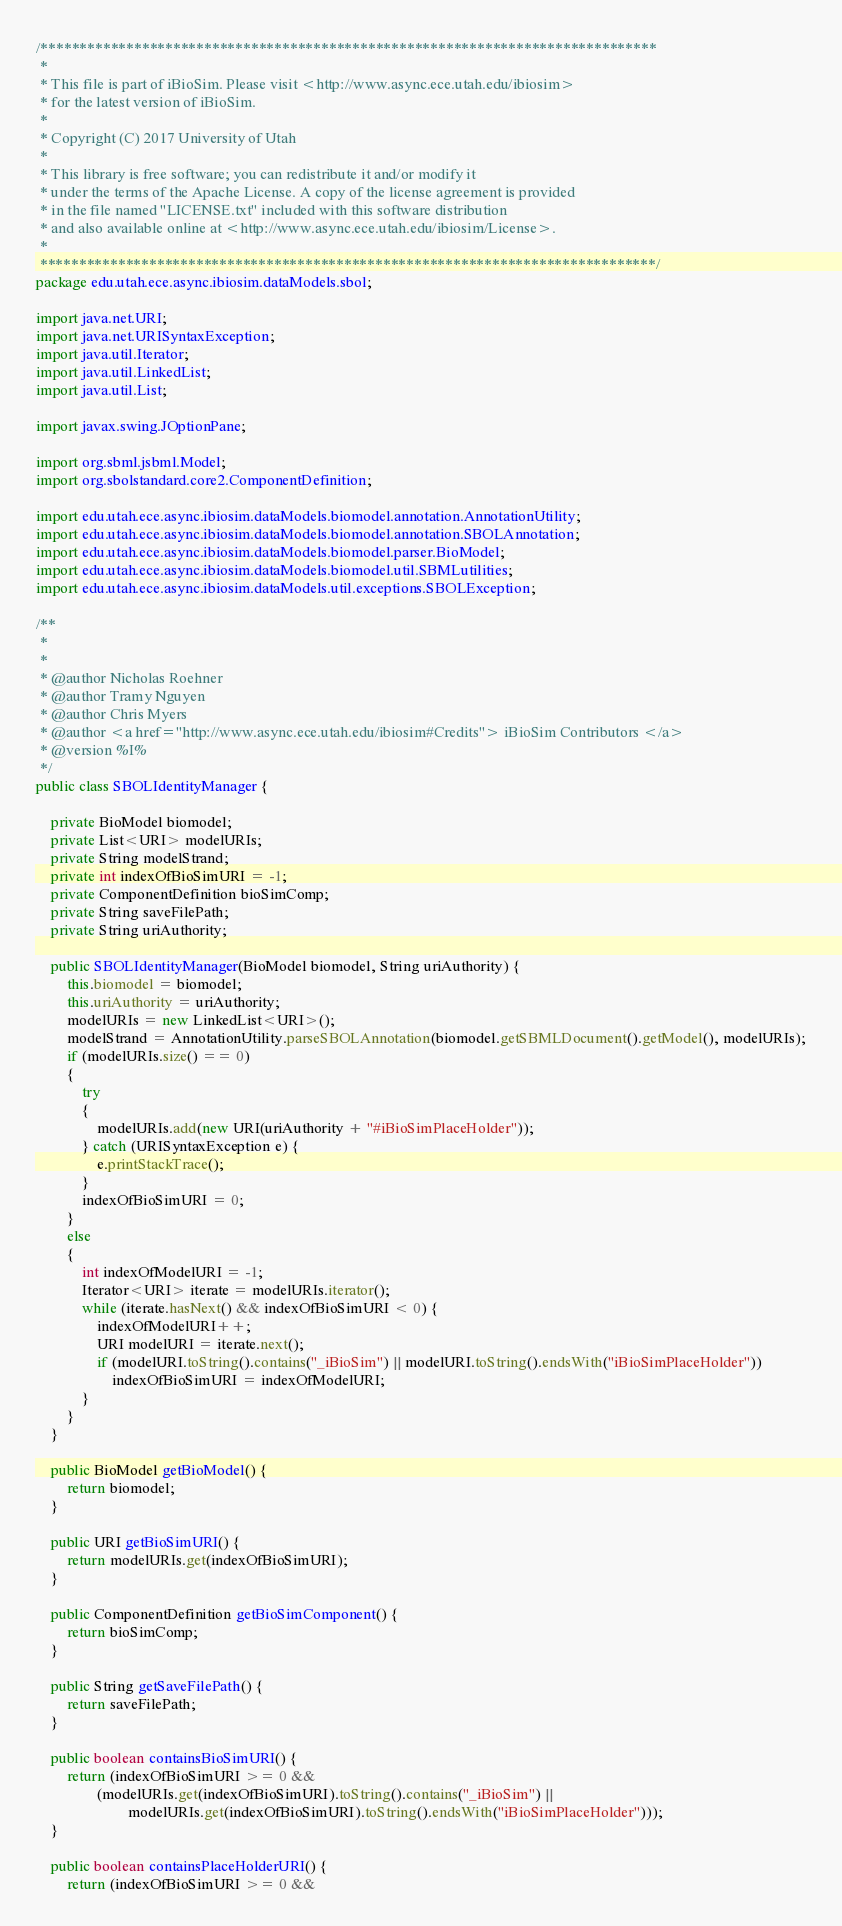<code> <loc_0><loc_0><loc_500><loc_500><_Java_>/*******************************************************************************
 *  
 * This file is part of iBioSim. Please visit <http://www.async.ece.utah.edu/ibiosim>
 * for the latest version of iBioSim.
 *
 * Copyright (C) 2017 University of Utah
 *
 * This library is free software; you can redistribute it and/or modify it
 * under the terms of the Apache License. A copy of the license agreement is provided
 * in the file named "LICENSE.txt" included with this software distribution
 * and also available online at <http://www.async.ece.utah.edu/ibiosim/License>.
 *  
 *******************************************************************************/
package edu.utah.ece.async.ibiosim.dataModels.sbol;

import java.net.URI;
import java.net.URISyntaxException;
import java.util.Iterator;
import java.util.LinkedList;
import java.util.List;

import javax.swing.JOptionPane;

import org.sbml.jsbml.Model;
import org.sbolstandard.core2.ComponentDefinition;

import edu.utah.ece.async.ibiosim.dataModels.biomodel.annotation.AnnotationUtility;
import edu.utah.ece.async.ibiosim.dataModels.biomodel.annotation.SBOLAnnotation;
import edu.utah.ece.async.ibiosim.dataModels.biomodel.parser.BioModel;
import edu.utah.ece.async.ibiosim.dataModels.biomodel.util.SBMLutilities;
import edu.utah.ece.async.ibiosim.dataModels.util.exceptions.SBOLException;

/**
 * 
 *
 * @author Nicholas Roehner
 * @author Tramy Nguyen
 * @author Chris Myers
 * @author <a href="http://www.async.ece.utah.edu/ibiosim#Credits"> iBioSim Contributors </a>
 * @version %I%
 */
public class SBOLIdentityManager {

	private BioModel biomodel;
	private List<URI> modelURIs;
	private String modelStrand;
	private int indexOfBioSimURI = -1;
	private ComponentDefinition bioSimComp;
	private String saveFilePath;
	private String uriAuthority;

	public SBOLIdentityManager(BioModel biomodel, String uriAuthority) {
		this.biomodel = biomodel;
		this.uriAuthority = uriAuthority;
		modelURIs = new LinkedList<URI>();
		modelStrand = AnnotationUtility.parseSBOLAnnotation(biomodel.getSBMLDocument().getModel(), modelURIs);
		if (modelURIs.size() == 0) 
		{
			try 
			{
				modelURIs.add(new URI(uriAuthority + "#iBioSimPlaceHolder"));
			} catch (URISyntaxException e) {
				e.printStackTrace();
			}
			indexOfBioSimURI = 0;
		} 
		else 
		{
			int indexOfModelURI = -1;
			Iterator<URI> iterate = modelURIs.iterator();
			while (iterate.hasNext() && indexOfBioSimURI < 0) {
				indexOfModelURI++;
				URI modelURI = iterate.next();
				if (modelURI.toString().contains("_iBioSim") || modelURI.toString().endsWith("iBioSimPlaceHolder"))
					indexOfBioSimURI = indexOfModelURI;
			} 
		}
	}
	
	public BioModel getBioModel() {
		return biomodel;
	}
	
	public URI getBioSimURI() {
		return modelURIs.get(indexOfBioSimURI);
	}
	
	public ComponentDefinition getBioSimComponent() {
		return bioSimComp;
	}
	
	public String getSaveFilePath() {
		return saveFilePath;
	}
	
	public boolean containsBioSimURI() {
		return (indexOfBioSimURI >= 0 && 
				(modelURIs.get(indexOfBioSimURI).toString().contains("_iBioSim") || 
						modelURIs.get(indexOfBioSimURI).toString().endsWith("iBioSimPlaceHolder")));
	}
	
	public boolean containsPlaceHolderURI() {
		return (indexOfBioSimURI >= 0 && </code> 